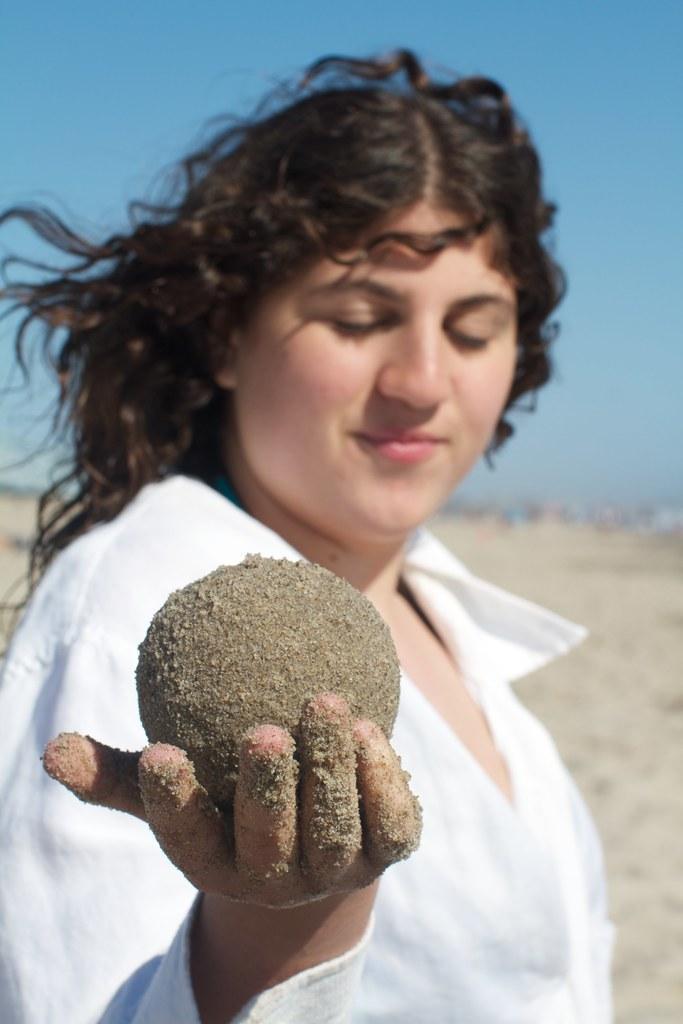In one or two sentences, can you explain what this image depicts? In this picture I can observe a woman holding a sand ball in her hand. She is wearing white color dress. In the background I can observe sky. 